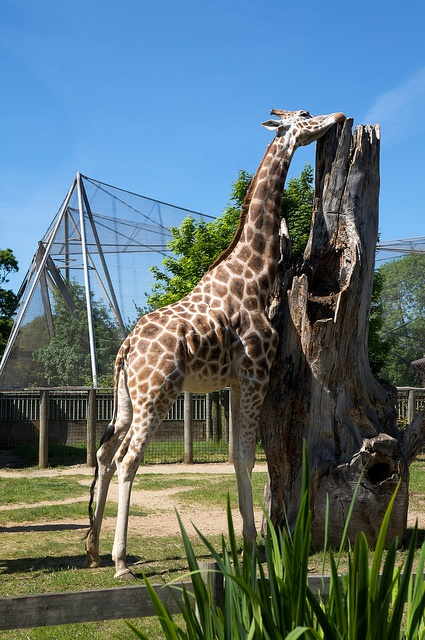Describe the objects in this image and their specific colors. I can see a giraffe in gray, black, and ivory tones in this image. 